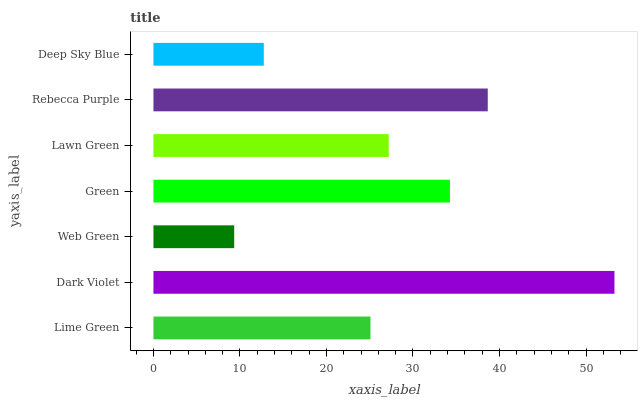Is Web Green the minimum?
Answer yes or no. Yes. Is Dark Violet the maximum?
Answer yes or no. Yes. Is Dark Violet the minimum?
Answer yes or no. No. Is Web Green the maximum?
Answer yes or no. No. Is Dark Violet greater than Web Green?
Answer yes or no. Yes. Is Web Green less than Dark Violet?
Answer yes or no. Yes. Is Web Green greater than Dark Violet?
Answer yes or no. No. Is Dark Violet less than Web Green?
Answer yes or no. No. Is Lawn Green the high median?
Answer yes or no. Yes. Is Lawn Green the low median?
Answer yes or no. Yes. Is Web Green the high median?
Answer yes or no. No. Is Rebecca Purple the low median?
Answer yes or no. No. 